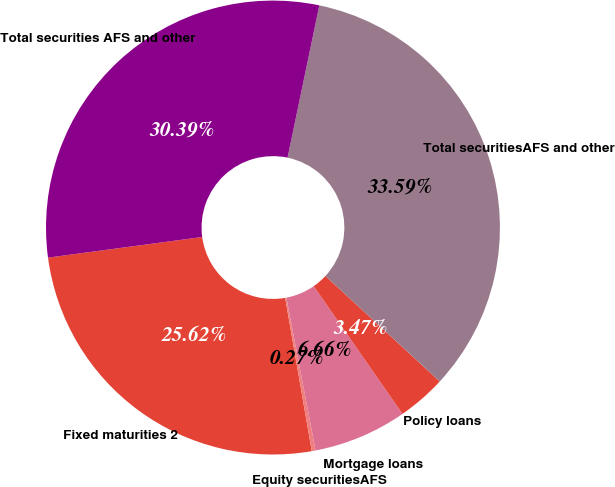<chart> <loc_0><loc_0><loc_500><loc_500><pie_chart><fcel>Fixed maturities 2<fcel>Equity securitiesAFS<fcel>Mortgage loans<fcel>Policy loans<fcel>Total securitiesAFS and other<fcel>Total securities AFS and other<nl><fcel>25.62%<fcel>0.27%<fcel>6.66%<fcel>3.47%<fcel>33.59%<fcel>30.39%<nl></chart> 